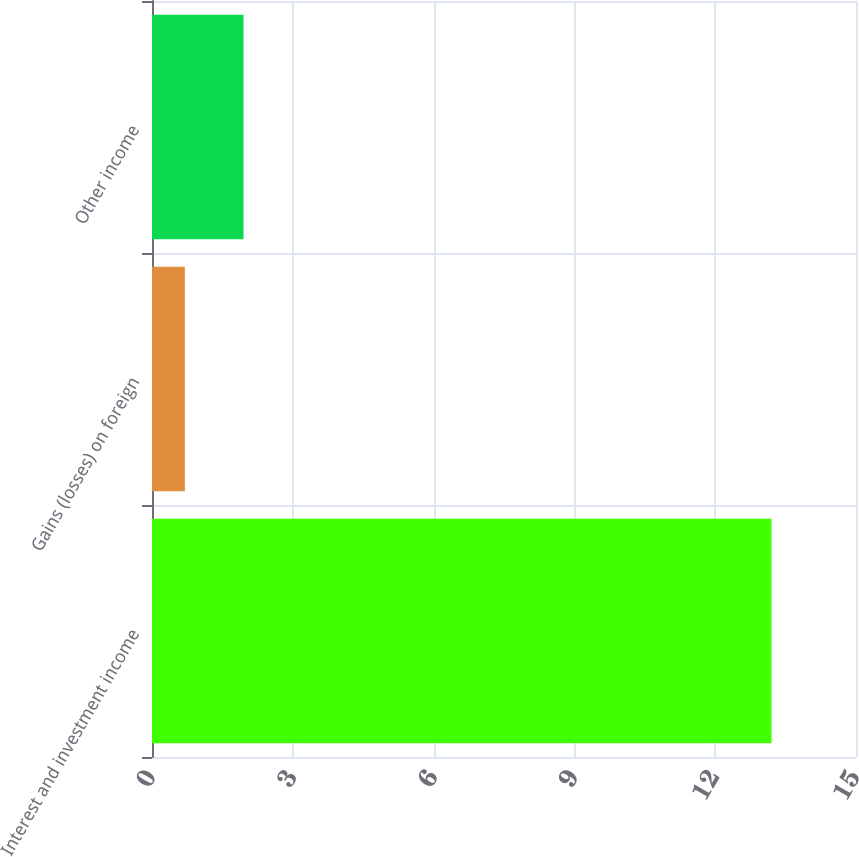Convert chart to OTSL. <chart><loc_0><loc_0><loc_500><loc_500><bar_chart><fcel>Interest and investment income<fcel>Gains (losses) on foreign<fcel>Other income<nl><fcel>13.2<fcel>0.7<fcel>1.95<nl></chart> 